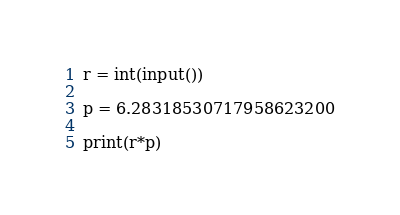<code> <loc_0><loc_0><loc_500><loc_500><_Python_>r = int(input())

p = 6.28318530717958623200

print(r*p)</code> 